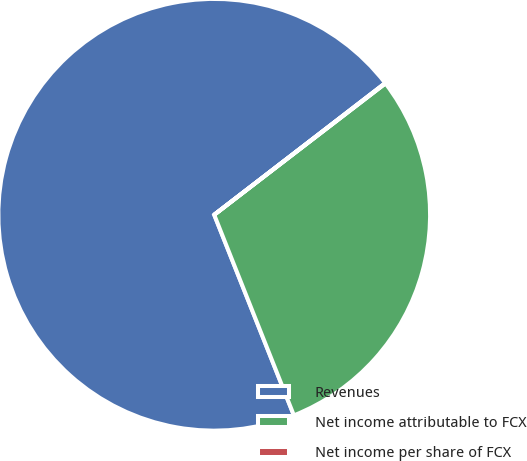<chart> <loc_0><loc_0><loc_500><loc_500><pie_chart><fcel>Revenues<fcel>Net income attributable to FCX<fcel>Net income per share of FCX<nl><fcel>70.57%<fcel>29.4%<fcel>0.03%<nl></chart> 